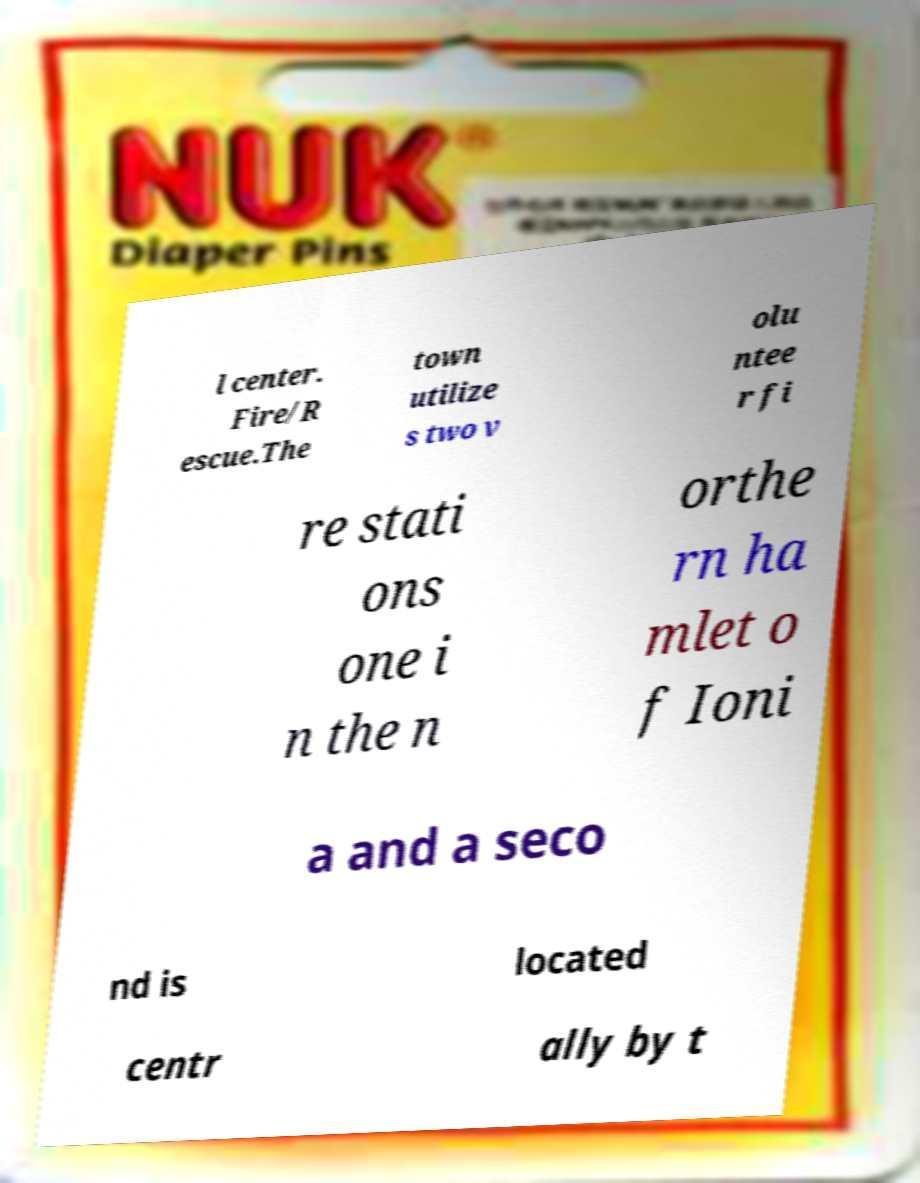Could you extract and type out the text from this image? l center. Fire/R escue.The town utilize s two v olu ntee r fi re stati ons one i n the n orthe rn ha mlet o f Ioni a and a seco nd is located centr ally by t 